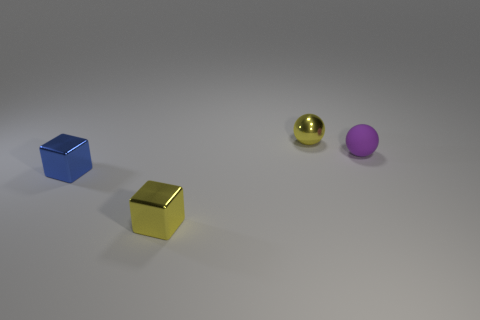Add 2 tiny red cubes. How many objects exist? 6 Add 4 tiny blocks. How many tiny blocks are left? 6 Add 3 small metallic cubes. How many small metallic cubes exist? 5 Subtract 1 yellow spheres. How many objects are left? 3 Subtract all cyan rubber objects. Subtract all small cubes. How many objects are left? 2 